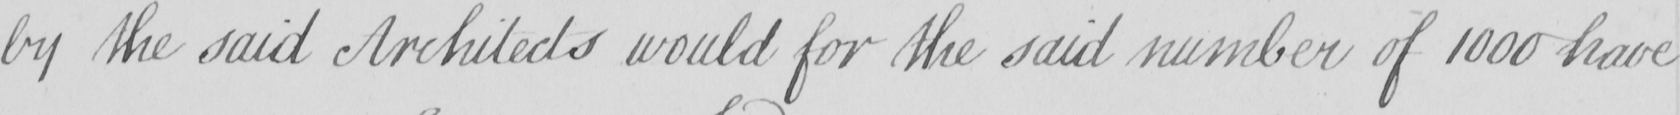What text is written in this handwritten line? by the said Architects would for the said number of 1000 have 